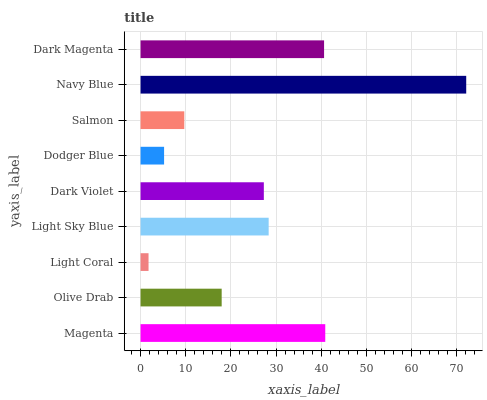Is Light Coral the minimum?
Answer yes or no. Yes. Is Navy Blue the maximum?
Answer yes or no. Yes. Is Olive Drab the minimum?
Answer yes or no. No. Is Olive Drab the maximum?
Answer yes or no. No. Is Magenta greater than Olive Drab?
Answer yes or no. Yes. Is Olive Drab less than Magenta?
Answer yes or no. Yes. Is Olive Drab greater than Magenta?
Answer yes or no. No. Is Magenta less than Olive Drab?
Answer yes or no. No. Is Dark Violet the high median?
Answer yes or no. Yes. Is Dark Violet the low median?
Answer yes or no. Yes. Is Light Sky Blue the high median?
Answer yes or no. No. Is Olive Drab the low median?
Answer yes or no. No. 